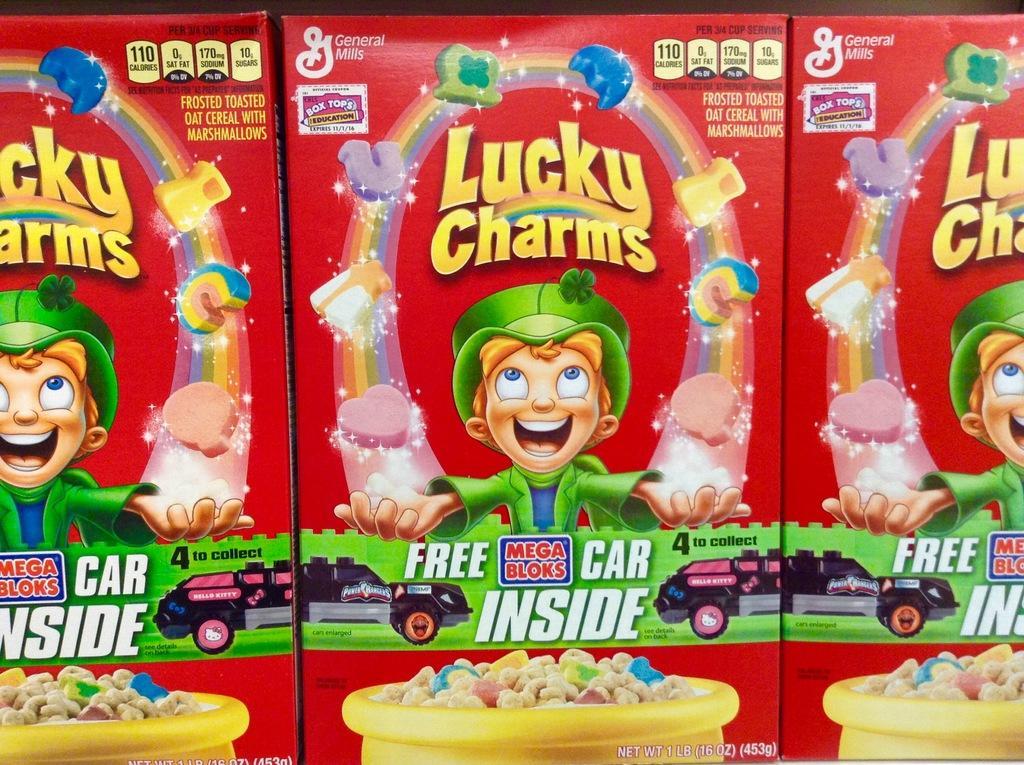Please provide a concise description of this image. In this image I see the boxes which are of red in color and I see the cartoon character on the boxes and I see few words, a car and yellow color bowl on which there is food. 